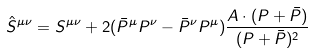<formula> <loc_0><loc_0><loc_500><loc_500>\hat { S } ^ { \mu \nu } = S ^ { \mu \nu } + 2 ( \bar { P } ^ { \mu } P ^ { \nu } - \bar { P } ^ { \nu } P ^ { \mu } ) \frac { A \cdot ( P + \bar { P } ) } { ( P + \bar { P } ) ^ { 2 } }</formula> 